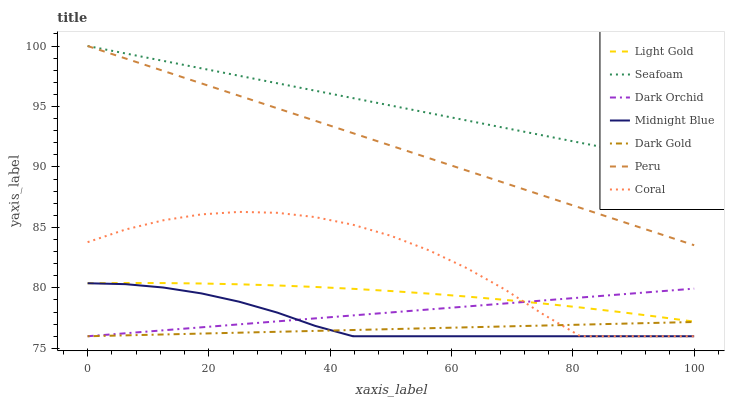Does Dark Gold have the minimum area under the curve?
Answer yes or no. Yes. Does Seafoam have the maximum area under the curve?
Answer yes or no. Yes. Does Coral have the minimum area under the curve?
Answer yes or no. No. Does Coral have the maximum area under the curve?
Answer yes or no. No. Is Dark Gold the smoothest?
Answer yes or no. Yes. Is Coral the roughest?
Answer yes or no. Yes. Is Coral the smoothest?
Answer yes or no. No. Is Dark Gold the roughest?
Answer yes or no. No. Does Midnight Blue have the lowest value?
Answer yes or no. Yes. Does Seafoam have the lowest value?
Answer yes or no. No. Does Peru have the highest value?
Answer yes or no. Yes. Does Coral have the highest value?
Answer yes or no. No. Is Midnight Blue less than Peru?
Answer yes or no. Yes. Is Seafoam greater than Midnight Blue?
Answer yes or no. Yes. Does Midnight Blue intersect Dark Orchid?
Answer yes or no. Yes. Is Midnight Blue less than Dark Orchid?
Answer yes or no. No. Is Midnight Blue greater than Dark Orchid?
Answer yes or no. No. Does Midnight Blue intersect Peru?
Answer yes or no. No. 